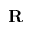<formula> <loc_0><loc_0><loc_500><loc_500>R</formula> 